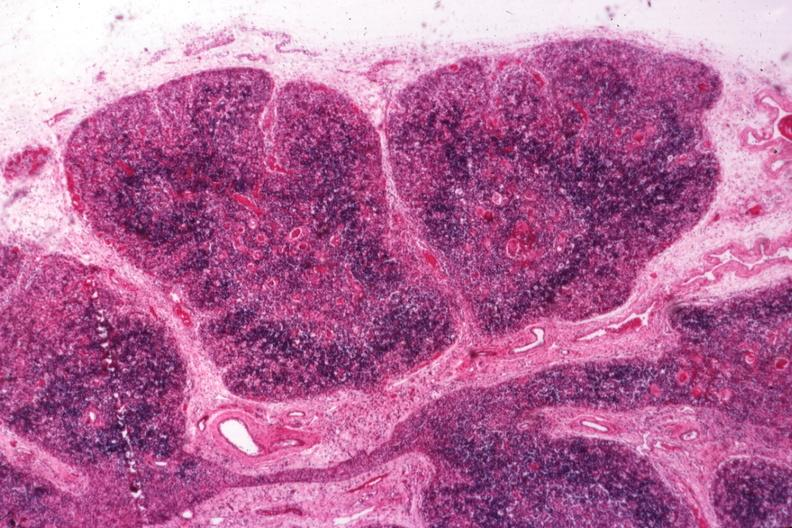what is present?
Answer the question using a single word or phrase. Thymus 